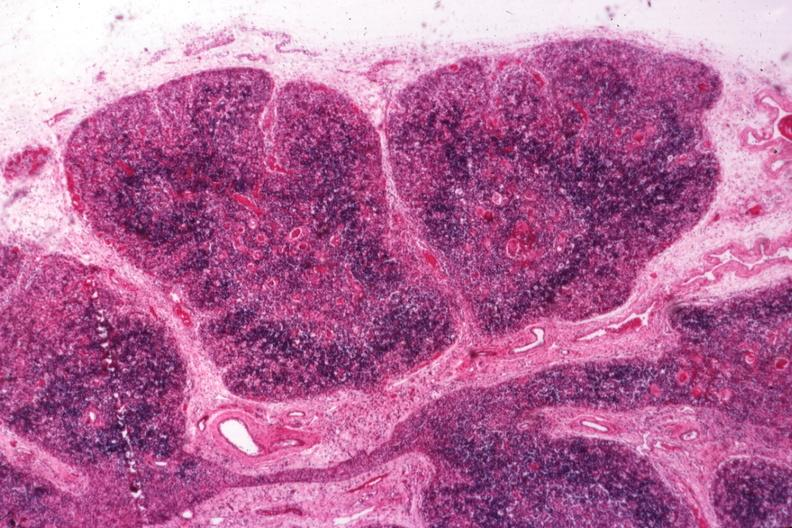what is present?
Answer the question using a single word or phrase. Thymus 